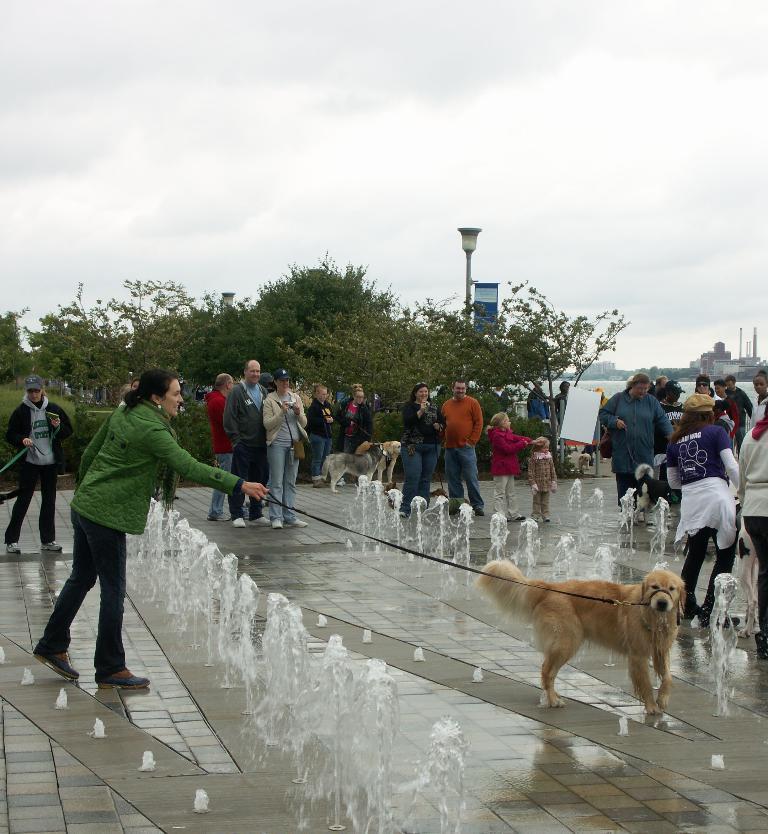Could you give a brief overview of what you see in this image? In this picture we can see so many people are standing and summer walking one woman is holding a belt to control the dog in between them the water flow is there in back side we can see some of the trees Sky. 